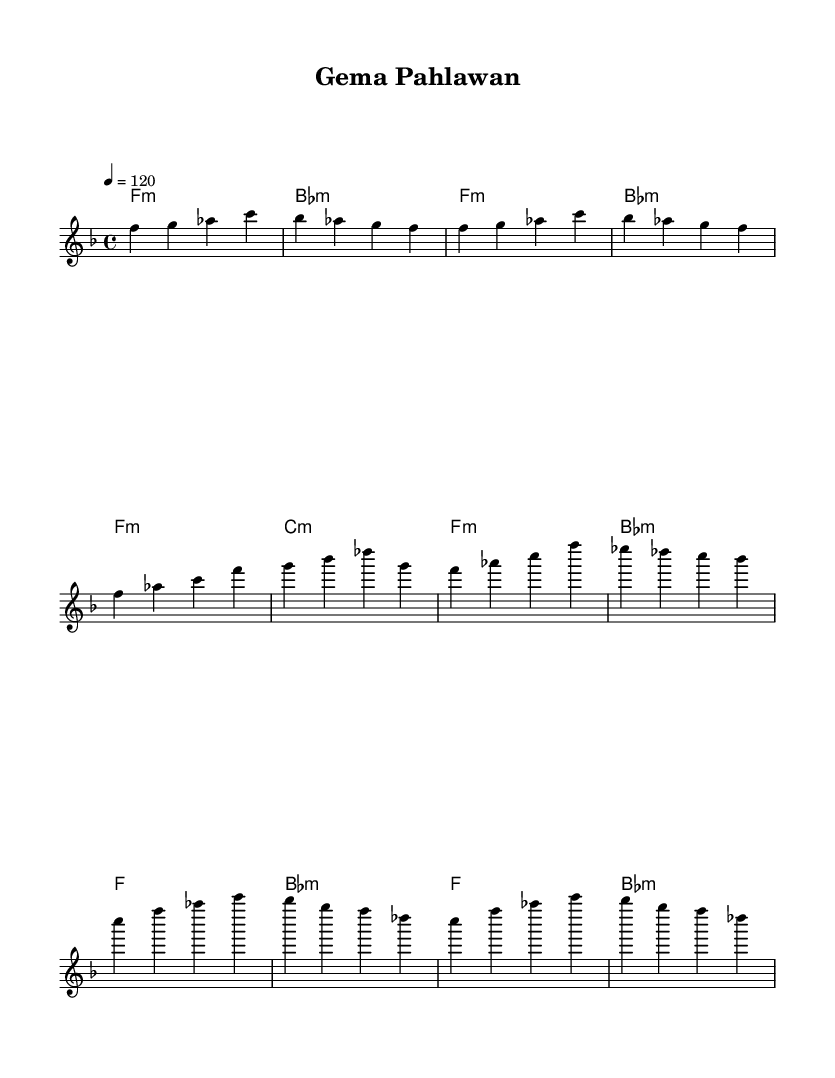What is the key signature of this music? The key signature is indicated by the number of flats or sharps at the beginning of the staff. Here, we see one flat, which corresponds to F major.
Answer: F major What is the time signature? The time signature is given after the key signature and is shown as a fraction. Here, we see 4/4, meaning there are four beats in each measure and the quarter note gets one beat.
Answer: 4/4 What is the tempo marking? The tempo is indicated at the beginning of the score with beats per minute. Here, the tempo is set to 120 beats per minute.
Answer: 120 How many measures are present in the chorus section? To find the number of measures in the chorus, count the distinct segments divided by the vertical lines (bar lines). Counting from the start of the chorus, there are four measures.
Answer: 4 What is the structure of the piece? The structure can be inferred from the sections labeled in the sheet music. Here, the piece consists of an Intro, a Verse, and a Chorus.
Answer: Intro, Verse, Chorus What type of harmony is primarily used in this piece? The harmony is indicated by the chord names, which show mostly minor chords throughout the piece. Checking the chord symbols, we see that most are labeled with 'm', indicating minor.
Answer: Minor Which traditional Indonesian instrument is most likely referenced in the melody? The melody features characteristic sounds that resemble the gamelan's use of bronze percussion instruments like bronze instruments. The use of floating melodic phrases is typical of gamelan's influence in this piece.
Answer: Gamelan 